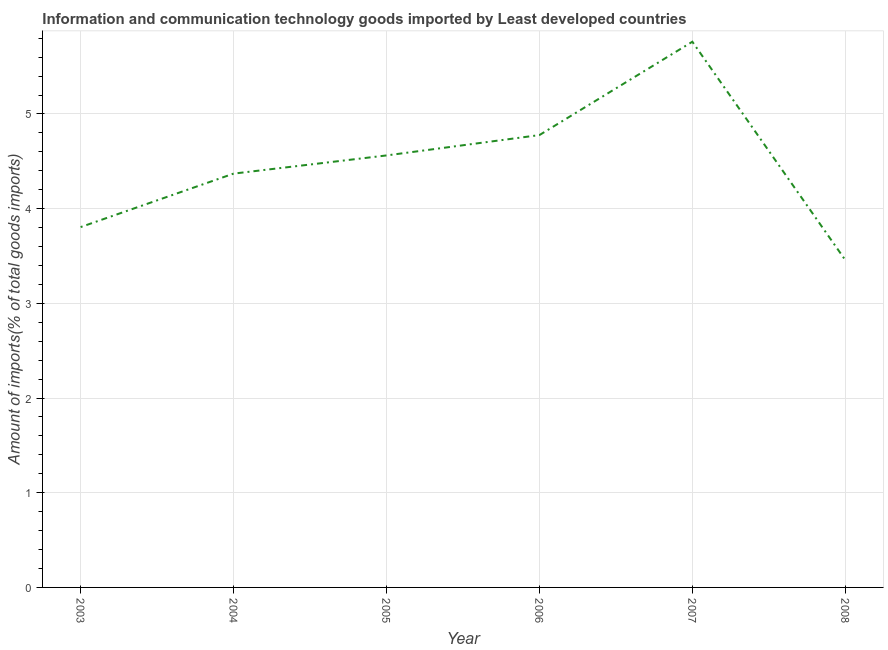What is the amount of ict goods imports in 2005?
Offer a terse response. 4.56. Across all years, what is the maximum amount of ict goods imports?
Your answer should be compact. 5.76. Across all years, what is the minimum amount of ict goods imports?
Keep it short and to the point. 3.46. In which year was the amount of ict goods imports maximum?
Give a very brief answer. 2007. In which year was the amount of ict goods imports minimum?
Provide a succinct answer. 2008. What is the sum of the amount of ict goods imports?
Your response must be concise. 26.73. What is the difference between the amount of ict goods imports in 2006 and 2007?
Provide a short and direct response. -0.99. What is the average amount of ict goods imports per year?
Your response must be concise. 4.46. What is the median amount of ict goods imports?
Your answer should be very brief. 4.47. In how many years, is the amount of ict goods imports greater than 2.8 %?
Offer a very short reply. 6. What is the ratio of the amount of ict goods imports in 2003 to that in 2008?
Your response must be concise. 1.1. What is the difference between the highest and the second highest amount of ict goods imports?
Keep it short and to the point. 0.99. What is the difference between the highest and the lowest amount of ict goods imports?
Offer a very short reply. 2.31. Does the amount of ict goods imports monotonically increase over the years?
Your response must be concise. No. How many lines are there?
Give a very brief answer. 1. How many years are there in the graph?
Give a very brief answer. 6. Are the values on the major ticks of Y-axis written in scientific E-notation?
Offer a terse response. No. Does the graph contain any zero values?
Give a very brief answer. No. What is the title of the graph?
Give a very brief answer. Information and communication technology goods imported by Least developed countries. What is the label or title of the X-axis?
Keep it short and to the point. Year. What is the label or title of the Y-axis?
Give a very brief answer. Amount of imports(% of total goods imports). What is the Amount of imports(% of total goods imports) in 2003?
Keep it short and to the point. 3.81. What is the Amount of imports(% of total goods imports) of 2004?
Make the answer very short. 4.37. What is the Amount of imports(% of total goods imports) of 2005?
Your response must be concise. 4.56. What is the Amount of imports(% of total goods imports) in 2006?
Your answer should be compact. 4.78. What is the Amount of imports(% of total goods imports) in 2007?
Your answer should be very brief. 5.76. What is the Amount of imports(% of total goods imports) in 2008?
Keep it short and to the point. 3.46. What is the difference between the Amount of imports(% of total goods imports) in 2003 and 2004?
Offer a terse response. -0.56. What is the difference between the Amount of imports(% of total goods imports) in 2003 and 2005?
Ensure brevity in your answer.  -0.76. What is the difference between the Amount of imports(% of total goods imports) in 2003 and 2006?
Keep it short and to the point. -0.97. What is the difference between the Amount of imports(% of total goods imports) in 2003 and 2007?
Your answer should be very brief. -1.96. What is the difference between the Amount of imports(% of total goods imports) in 2003 and 2008?
Offer a very short reply. 0.35. What is the difference between the Amount of imports(% of total goods imports) in 2004 and 2005?
Offer a very short reply. -0.19. What is the difference between the Amount of imports(% of total goods imports) in 2004 and 2006?
Keep it short and to the point. -0.41. What is the difference between the Amount of imports(% of total goods imports) in 2004 and 2007?
Keep it short and to the point. -1.39. What is the difference between the Amount of imports(% of total goods imports) in 2004 and 2008?
Your answer should be very brief. 0.91. What is the difference between the Amount of imports(% of total goods imports) in 2005 and 2006?
Provide a succinct answer. -0.21. What is the difference between the Amount of imports(% of total goods imports) in 2005 and 2007?
Offer a very short reply. -1.2. What is the difference between the Amount of imports(% of total goods imports) in 2005 and 2008?
Offer a very short reply. 1.1. What is the difference between the Amount of imports(% of total goods imports) in 2006 and 2007?
Make the answer very short. -0.99. What is the difference between the Amount of imports(% of total goods imports) in 2006 and 2008?
Make the answer very short. 1.32. What is the difference between the Amount of imports(% of total goods imports) in 2007 and 2008?
Provide a short and direct response. 2.31. What is the ratio of the Amount of imports(% of total goods imports) in 2003 to that in 2004?
Provide a short and direct response. 0.87. What is the ratio of the Amount of imports(% of total goods imports) in 2003 to that in 2005?
Your answer should be compact. 0.83. What is the ratio of the Amount of imports(% of total goods imports) in 2003 to that in 2006?
Provide a short and direct response. 0.8. What is the ratio of the Amount of imports(% of total goods imports) in 2003 to that in 2007?
Provide a succinct answer. 0.66. What is the ratio of the Amount of imports(% of total goods imports) in 2003 to that in 2008?
Keep it short and to the point. 1.1. What is the ratio of the Amount of imports(% of total goods imports) in 2004 to that in 2005?
Give a very brief answer. 0.96. What is the ratio of the Amount of imports(% of total goods imports) in 2004 to that in 2006?
Keep it short and to the point. 0.92. What is the ratio of the Amount of imports(% of total goods imports) in 2004 to that in 2007?
Your response must be concise. 0.76. What is the ratio of the Amount of imports(% of total goods imports) in 2004 to that in 2008?
Your answer should be very brief. 1.26. What is the ratio of the Amount of imports(% of total goods imports) in 2005 to that in 2006?
Give a very brief answer. 0.95. What is the ratio of the Amount of imports(% of total goods imports) in 2005 to that in 2007?
Your answer should be very brief. 0.79. What is the ratio of the Amount of imports(% of total goods imports) in 2005 to that in 2008?
Keep it short and to the point. 1.32. What is the ratio of the Amount of imports(% of total goods imports) in 2006 to that in 2007?
Offer a very short reply. 0.83. What is the ratio of the Amount of imports(% of total goods imports) in 2006 to that in 2008?
Make the answer very short. 1.38. What is the ratio of the Amount of imports(% of total goods imports) in 2007 to that in 2008?
Your response must be concise. 1.67. 